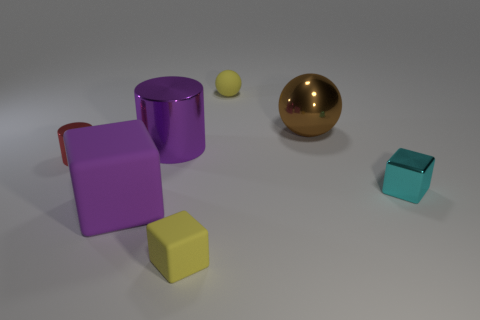There is a yellow rubber object in front of the tiny yellow matte sphere left of the brown ball; are there any tiny red shiny objects that are right of it?
Provide a short and direct response. No. Is the number of big purple things behind the matte sphere less than the number of brown balls that are in front of the cyan metal cube?
Your response must be concise. No. What number of large brown objects have the same material as the tiny yellow cube?
Provide a short and direct response. 0. There is a purple block; is it the same size as the purple object behind the red metallic cylinder?
Keep it short and to the point. Yes. What is the material of the tiny object that is the same color as the small matte cube?
Your answer should be very brief. Rubber. What size is the cube to the right of the tiny yellow object to the right of the small block in front of the big purple cube?
Provide a short and direct response. Small. Is the number of small blocks that are behind the big block greater than the number of big purple metal things behind the small shiny block?
Provide a succinct answer. No. There is a tiny cube behind the purple cube; what number of tiny yellow matte cubes are on the right side of it?
Ensure brevity in your answer.  0. Is there a big matte block that has the same color as the big ball?
Your answer should be compact. No. Do the shiny sphere and the yellow block have the same size?
Provide a succinct answer. No. 